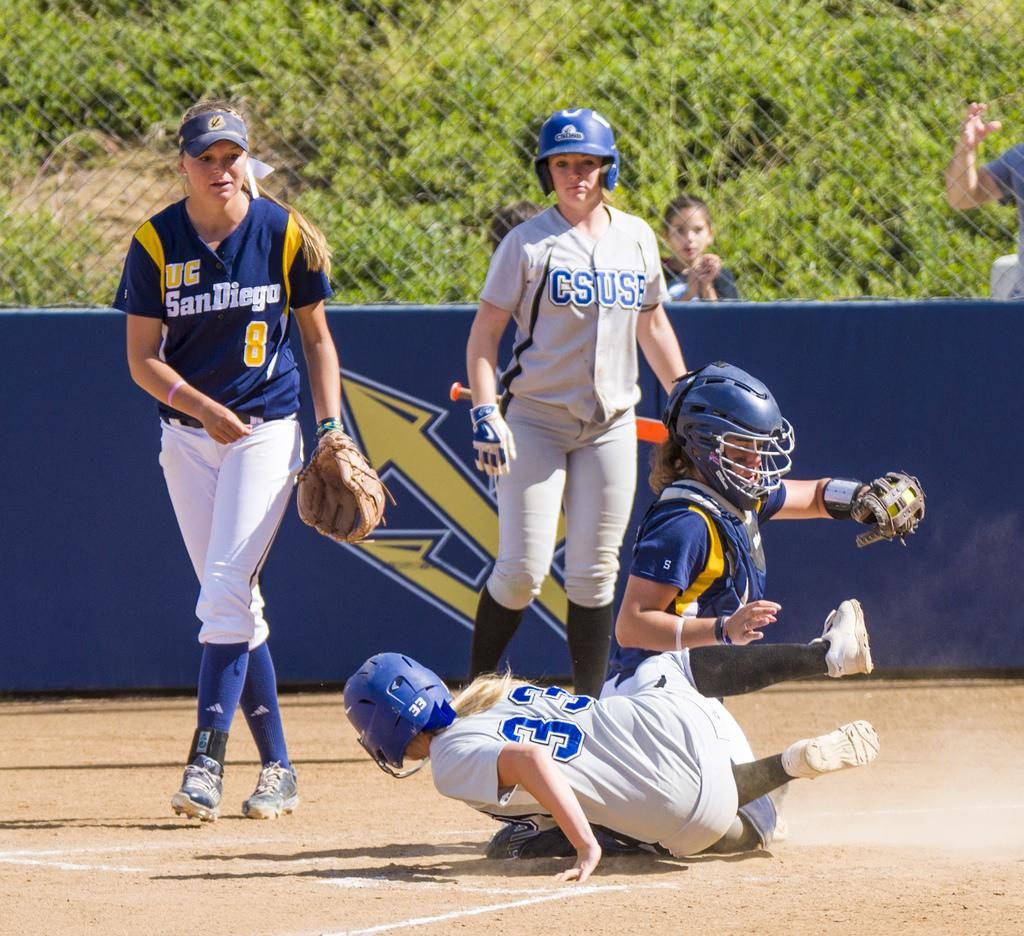<image>
Write a terse but informative summary of the picture. A girls' baseball game is in progress with one team having UC SanDiego on the uniforms. 